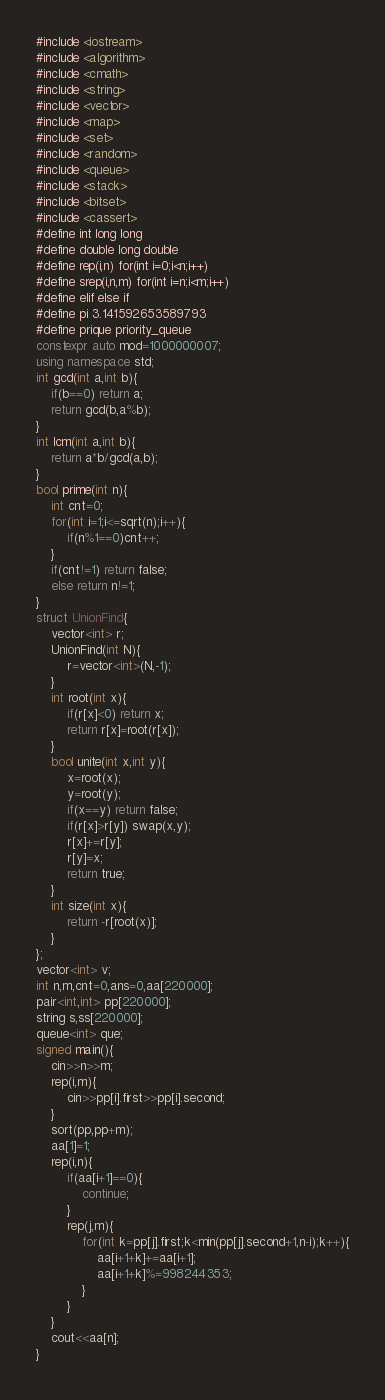Convert code to text. <code><loc_0><loc_0><loc_500><loc_500><_C++_>#include <iostream>
#include <algorithm>
#include <cmath>
#include <string>
#include <vector>
#include <map>
#include <set>
#include <random>
#include <queue>
#include <stack>
#include <bitset>
#include <cassert>
#define int long long
#define double long double
#define rep(i,n) for(int i=0;i<n;i++)
#define srep(i,n,m) for(int i=n;i<m;i++)
#define elif else if
#define pi 3.141592653589793
#define prique priority_queue
constexpr auto mod=1000000007;
using namespace std;
int gcd(int a,int b){
    if(b==0) return a;
    return gcd(b,a%b);
}
int lcm(int a,int b){
    return a*b/gcd(a,b);
}
bool prime(int n){
    int cnt=0;
    for(int i=1;i<=sqrt(n);i++){
        if(n%1==0)cnt++;
    }
    if(cnt!=1) return false;
    else return n!=1;
}
struct UnionFind{
    vector<int> r;
    UnionFind(int N){
        r=vector<int>(N,-1);
    }
    int root(int x){
        if(r[x]<0) return x;
        return r[x]=root(r[x]);
    }
    bool unite(int x,int y){
        x=root(x);
        y=root(y);
        if(x==y) return false;
        if(r[x]>r[y]) swap(x,y);
        r[x]+=r[y];
        r[y]=x;
        return true;
    }
    int size(int x){
        return -r[root(x)];
    }
};
vector<int> v;
int n,m,cnt=0,ans=0,aa[220000];
pair<int,int> pp[220000];
string s,ss[220000];
queue<int> que;
signed main(){
    cin>>n>>m;
    rep(i,m){
        cin>>pp[i].first>>pp[i].second;
    }
    sort(pp,pp+m);
    aa[1]=1;
    rep(i,n){
        if(aa[i+1]==0){
            continue;
        }
        rep(j,m){
            for(int k=pp[j].first;k<min(pp[j].second+1,n-i);k++){
                aa[i+1+k]+=aa[i+1];
                aa[i+1+k]%=998244353;
            }
        }
    }
    cout<<aa[n];
}</code> 